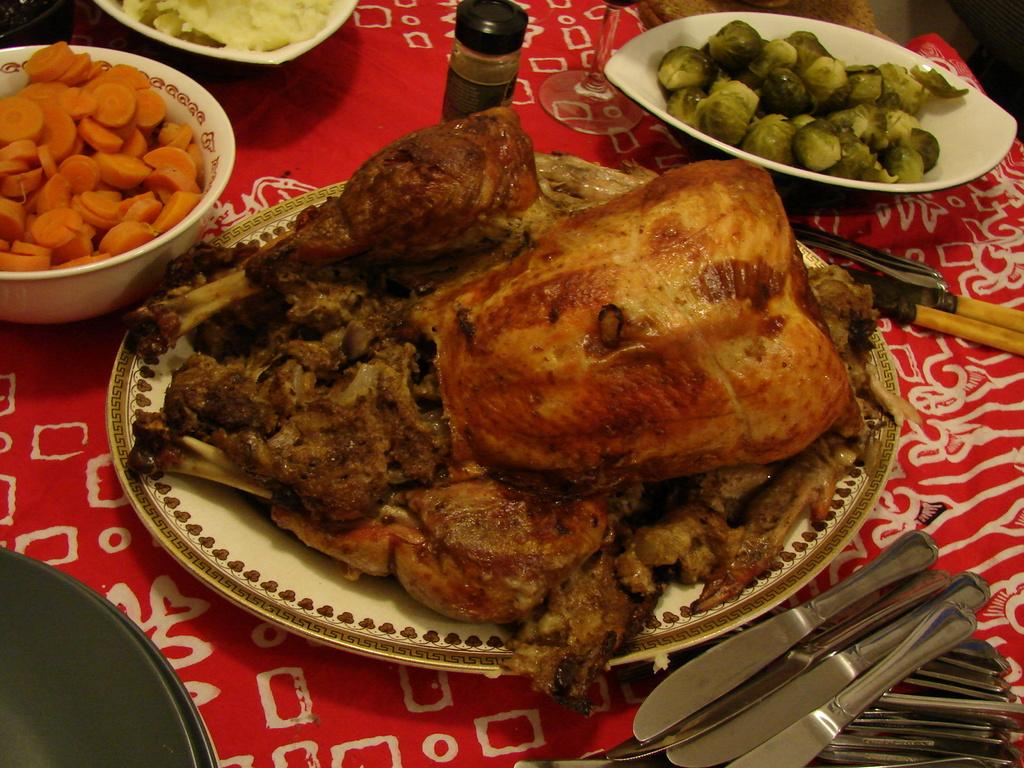What types of food items can be seen in the image? There are food items served in a plate and bowl in the image. What else is present on the table besides the food items? There are objects on the table in the image. How is the table decorated or covered in the image? The table is covered with a cloth. How many basketballs can be seen on the table in the image? There are no basketballs present in the image. What is the best way to wash the dishes in the image? There is no sink or any indication of dishes in the image, so it's not possible to determine the best way to wash them. 